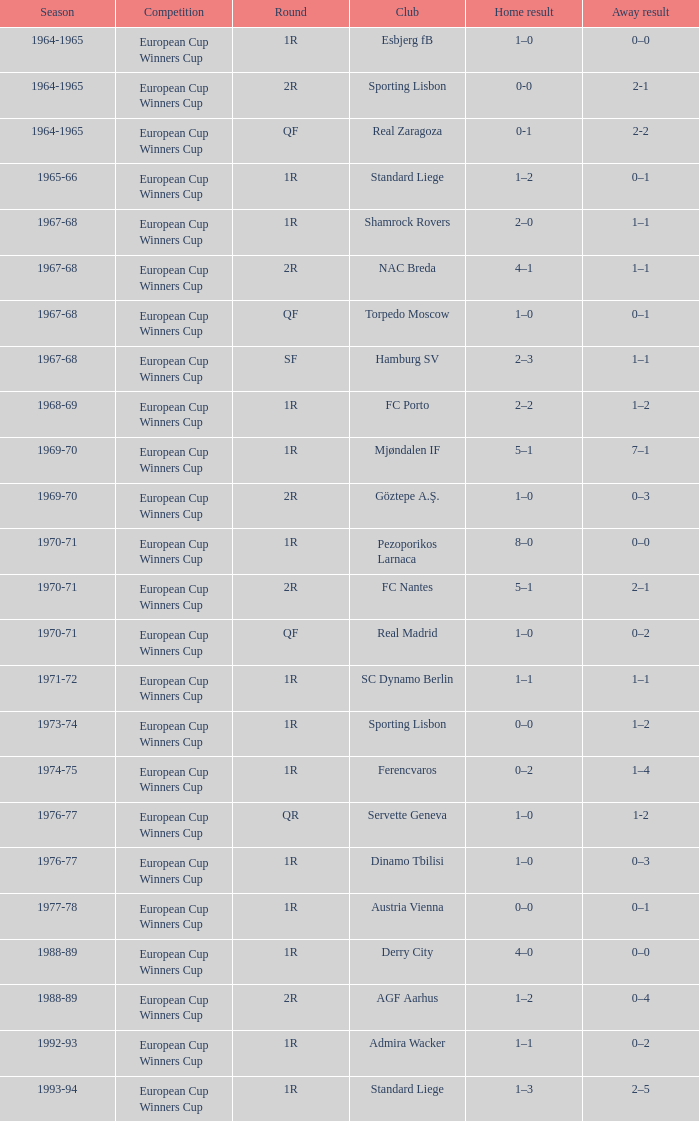What season features a 1st round and a 7-1 away outcome? 1969-70. 